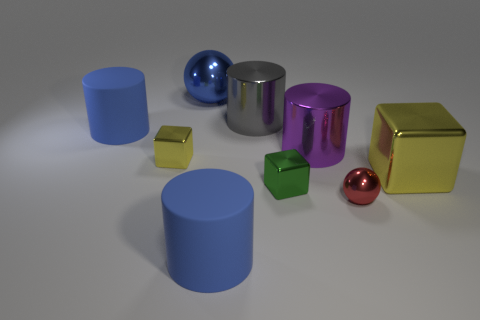The block that is to the right of the big cylinder on the right side of the big gray cylinder is what color?
Offer a very short reply. Yellow. Is there another cube of the same color as the big block?
Provide a short and direct response. Yes. There is a blue matte thing on the right side of the large blue matte object that is behind the big matte object that is right of the blue shiny ball; how big is it?
Ensure brevity in your answer.  Large. Is the shape of the red thing the same as the large blue matte thing in front of the green shiny block?
Provide a succinct answer. No. How many other objects are the same size as the gray object?
Keep it short and to the point. 5. What is the size of the yellow block to the right of the small red metallic thing?
Make the answer very short. Large. What number of large red cubes have the same material as the gray cylinder?
Make the answer very short. 0. Does the yellow thing that is to the left of the big metal ball have the same shape as the blue shiny object?
Make the answer very short. No. What shape is the big blue matte object that is behind the tiny red object?
Make the answer very short. Cylinder. What is the material of the tiny yellow object?
Your answer should be very brief. Metal. 